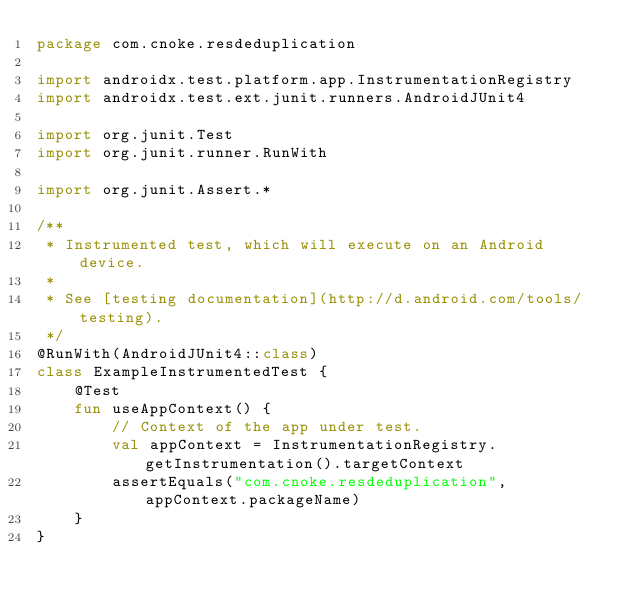<code> <loc_0><loc_0><loc_500><loc_500><_Kotlin_>package com.cnoke.resdeduplication

import androidx.test.platform.app.InstrumentationRegistry
import androidx.test.ext.junit.runners.AndroidJUnit4

import org.junit.Test
import org.junit.runner.RunWith

import org.junit.Assert.*

/**
 * Instrumented test, which will execute on an Android device.
 *
 * See [testing documentation](http://d.android.com/tools/testing).
 */
@RunWith(AndroidJUnit4::class)
class ExampleInstrumentedTest {
    @Test
    fun useAppContext() {
        // Context of the app under test.
        val appContext = InstrumentationRegistry.getInstrumentation().targetContext
        assertEquals("com.cnoke.resdeduplication", appContext.packageName)
    }
}</code> 